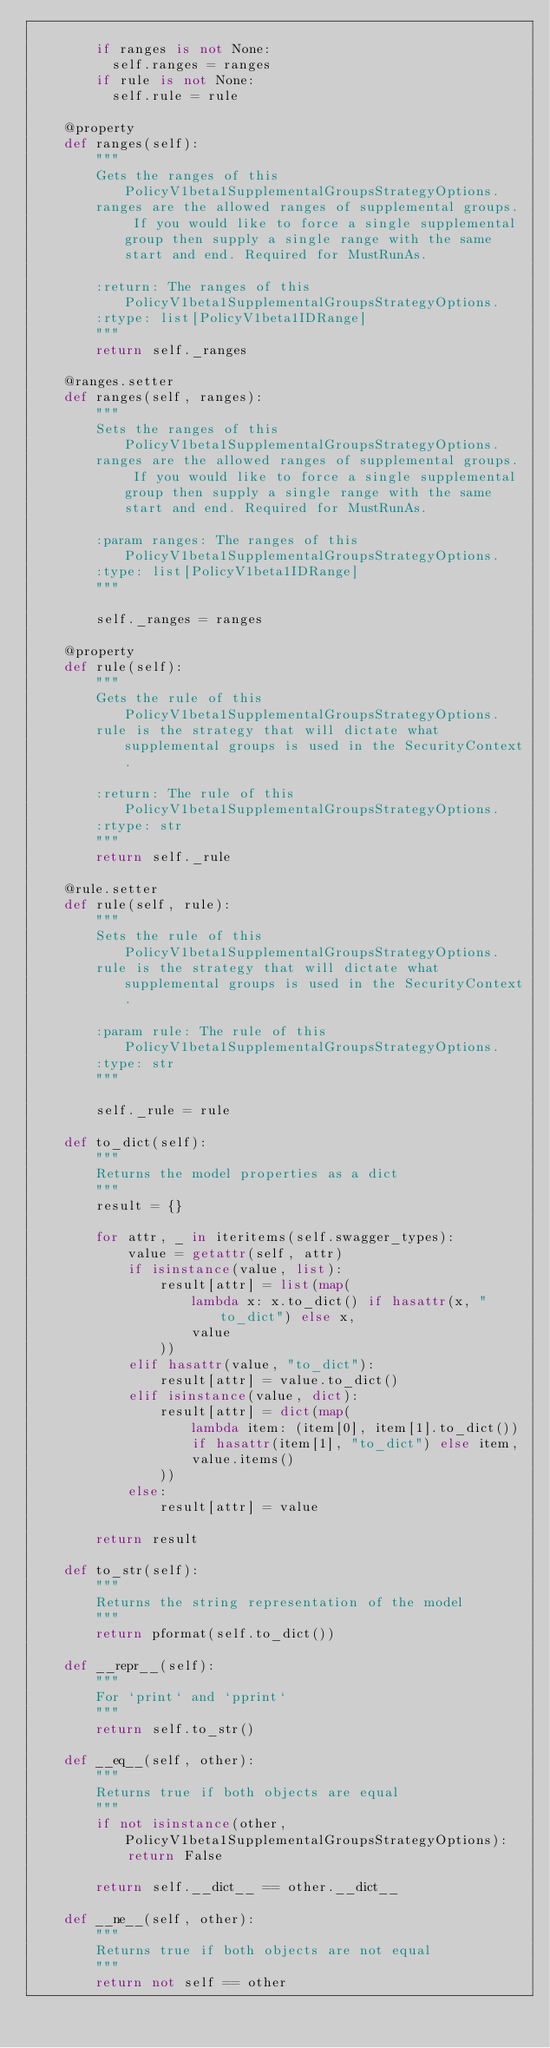Convert code to text. <code><loc_0><loc_0><loc_500><loc_500><_Python_>
        if ranges is not None:
          self.ranges = ranges
        if rule is not None:
          self.rule = rule

    @property
    def ranges(self):
        """
        Gets the ranges of this PolicyV1beta1SupplementalGroupsStrategyOptions.
        ranges are the allowed ranges of supplemental groups.  If you would like to force a single supplemental group then supply a single range with the same start and end. Required for MustRunAs.

        :return: The ranges of this PolicyV1beta1SupplementalGroupsStrategyOptions.
        :rtype: list[PolicyV1beta1IDRange]
        """
        return self._ranges

    @ranges.setter
    def ranges(self, ranges):
        """
        Sets the ranges of this PolicyV1beta1SupplementalGroupsStrategyOptions.
        ranges are the allowed ranges of supplemental groups.  If you would like to force a single supplemental group then supply a single range with the same start and end. Required for MustRunAs.

        :param ranges: The ranges of this PolicyV1beta1SupplementalGroupsStrategyOptions.
        :type: list[PolicyV1beta1IDRange]
        """

        self._ranges = ranges

    @property
    def rule(self):
        """
        Gets the rule of this PolicyV1beta1SupplementalGroupsStrategyOptions.
        rule is the strategy that will dictate what supplemental groups is used in the SecurityContext.

        :return: The rule of this PolicyV1beta1SupplementalGroupsStrategyOptions.
        :rtype: str
        """
        return self._rule

    @rule.setter
    def rule(self, rule):
        """
        Sets the rule of this PolicyV1beta1SupplementalGroupsStrategyOptions.
        rule is the strategy that will dictate what supplemental groups is used in the SecurityContext.

        :param rule: The rule of this PolicyV1beta1SupplementalGroupsStrategyOptions.
        :type: str
        """

        self._rule = rule

    def to_dict(self):
        """
        Returns the model properties as a dict
        """
        result = {}

        for attr, _ in iteritems(self.swagger_types):
            value = getattr(self, attr)
            if isinstance(value, list):
                result[attr] = list(map(
                    lambda x: x.to_dict() if hasattr(x, "to_dict") else x,
                    value
                ))
            elif hasattr(value, "to_dict"):
                result[attr] = value.to_dict()
            elif isinstance(value, dict):
                result[attr] = dict(map(
                    lambda item: (item[0], item[1].to_dict())
                    if hasattr(item[1], "to_dict") else item,
                    value.items()
                ))
            else:
                result[attr] = value

        return result

    def to_str(self):
        """
        Returns the string representation of the model
        """
        return pformat(self.to_dict())

    def __repr__(self):
        """
        For `print` and `pprint`
        """
        return self.to_str()

    def __eq__(self, other):
        """
        Returns true if both objects are equal
        """
        if not isinstance(other, PolicyV1beta1SupplementalGroupsStrategyOptions):
            return False

        return self.__dict__ == other.__dict__

    def __ne__(self, other):
        """
        Returns true if both objects are not equal
        """
        return not self == other
</code> 